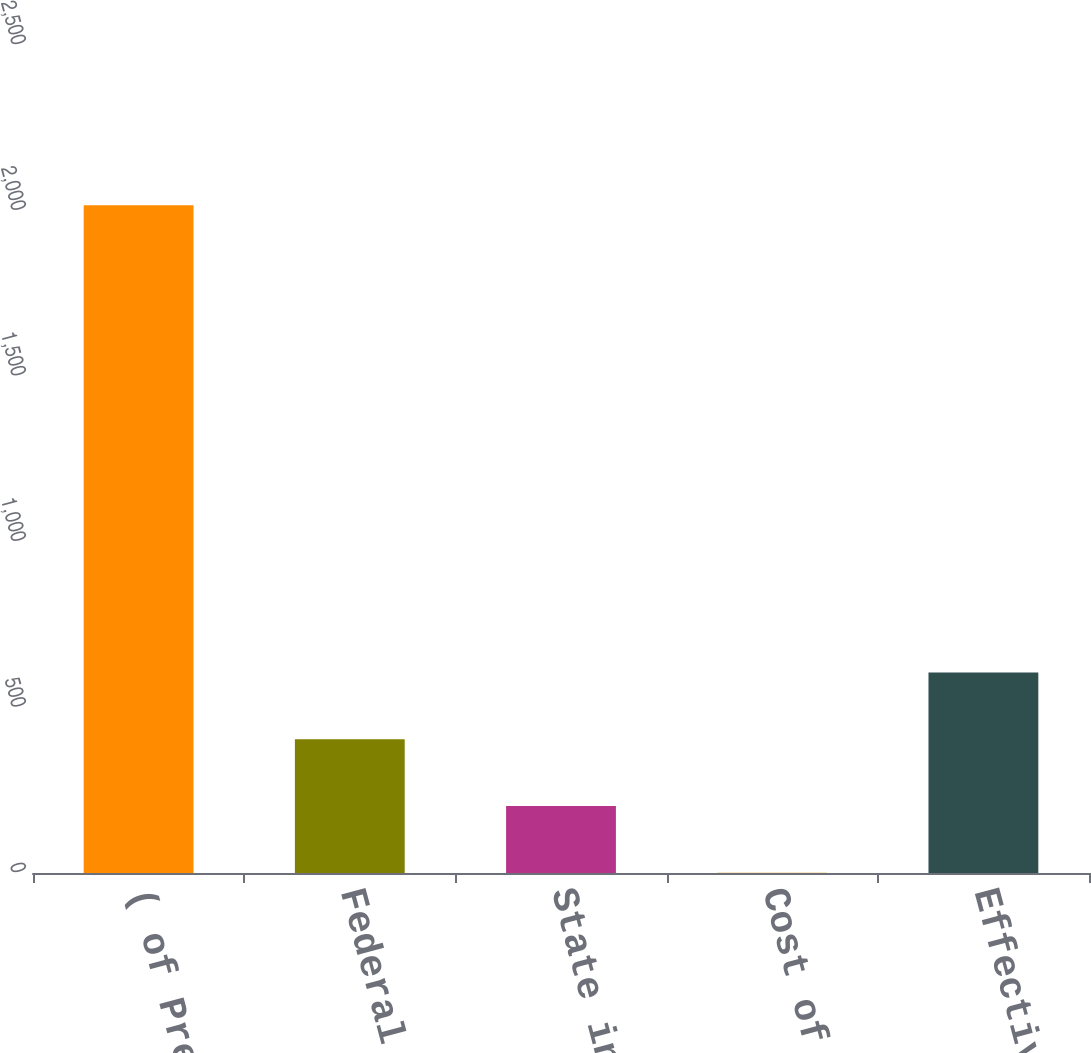Convert chart to OTSL. <chart><loc_0><loc_0><loc_500><loc_500><bar_chart><fcel>( of Pre-tax income)<fcel>Federal<fcel>State income tax<fcel>Cost of removal<fcel>Effective tax rate<nl><fcel>2016<fcel>404<fcel>202.5<fcel>1<fcel>605.5<nl></chart> 